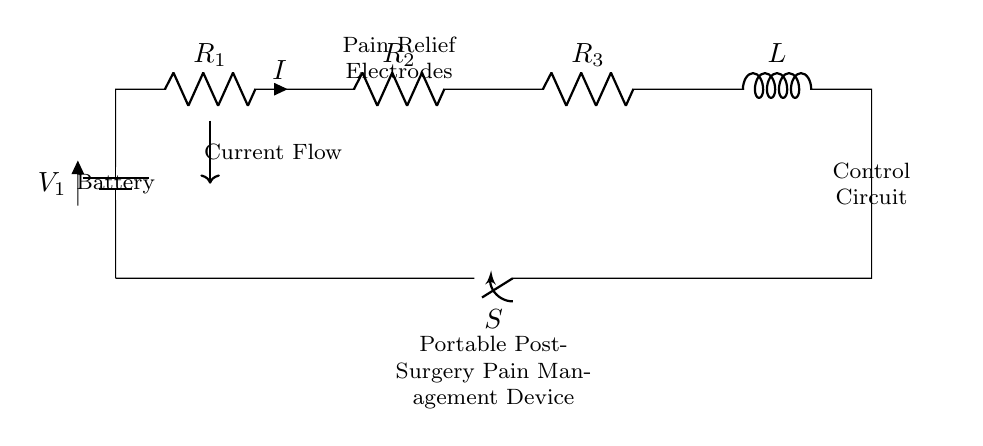What is the main power source of the circuit? The power source of the circuit is identified as a battery, labeled V1 in the diagram. This component provides the necessary voltage to the entire circuit.
Answer: Battery How many resistors are in this circuit? The diagram shows three resistors labeled R1, R2, and R3 connected in series. Counting these components gives us the total number of resistors.
Answer: Three What type of circuit is this? The circuit diagram depicts a series circuit where components are connected end-to-end, causing the same current to flow through each element. This is characteristic of series circuits.
Answer: Series What is the role of the inductor labeled L? The inductor, labeled L, is typically used in circuits to store energy in a magnetic field and can help in filtering or smoothing out current fluctuations in this application.
Answer: Filtering If the switch S is open, what happens to the current? When the switch S is open, it creates a disconnection in the circuit pathway, preventing any current flow. This can be inferred from the design where an open switch stops the circuit.
Answer: No current What happens if R1's resistance is increased? Increasing the resistance of R1 will reduce the current flowing through the entire series circuit according to Ohm's Law, assuming the voltage from the battery remains constant. This requires a deeper understanding of how resistance affects current in a series connection.
Answer: Current decreases What is the purpose of the pain relief electrodes in this circuit? The pain relief electrodes are intended to deliver electrical stimulation to the body, assisting with pain management post-surgery. This can be inferred from the labeling around the electrodes and the overall function of the device.
Answer: Pain management 